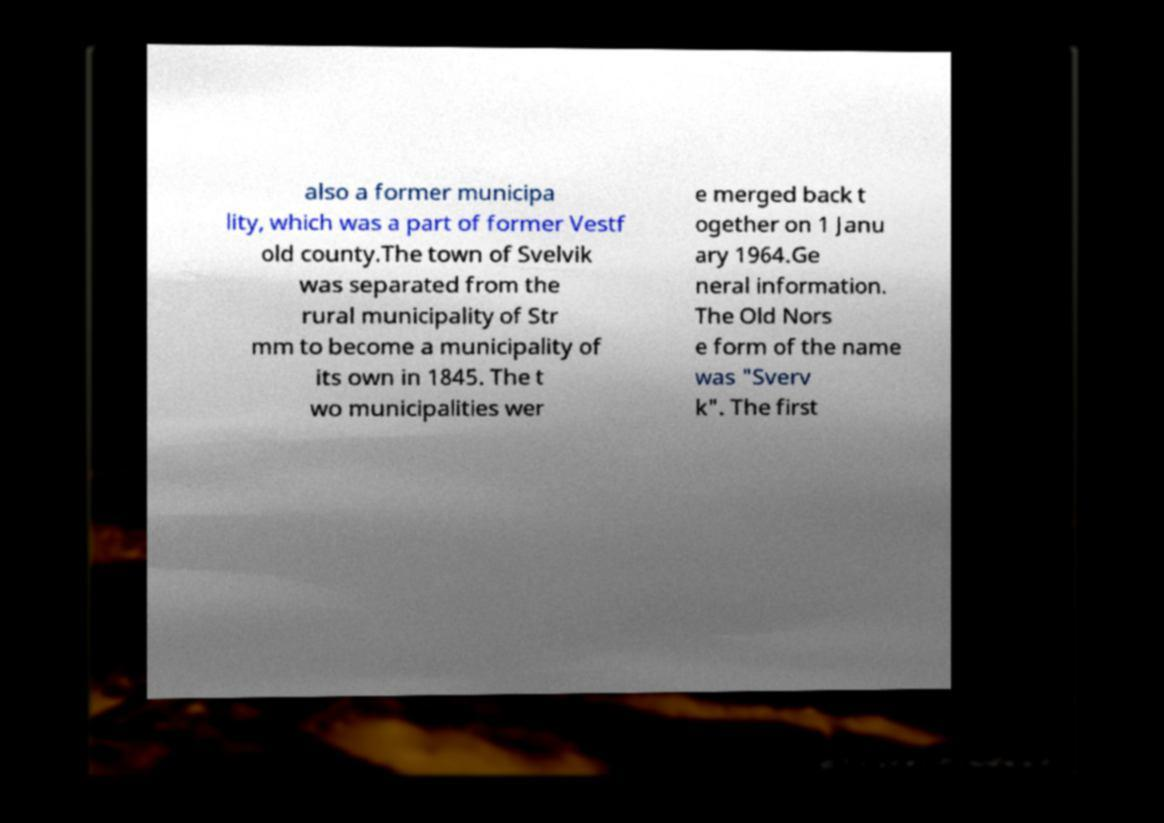Can you accurately transcribe the text from the provided image for me? also a former municipa lity, which was a part of former Vestf old county.The town of Svelvik was separated from the rural municipality of Str mm to become a municipality of its own in 1845. The t wo municipalities wer e merged back t ogether on 1 Janu ary 1964.Ge neral information. The Old Nors e form of the name was "Sverv k". The first 